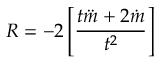Convert formula to latex. <formula><loc_0><loc_0><loc_500><loc_500>R = - 2 \left [ \frac { t \ddot { m } + 2 \dot { m } } { t ^ { 2 } } \right ]</formula> 